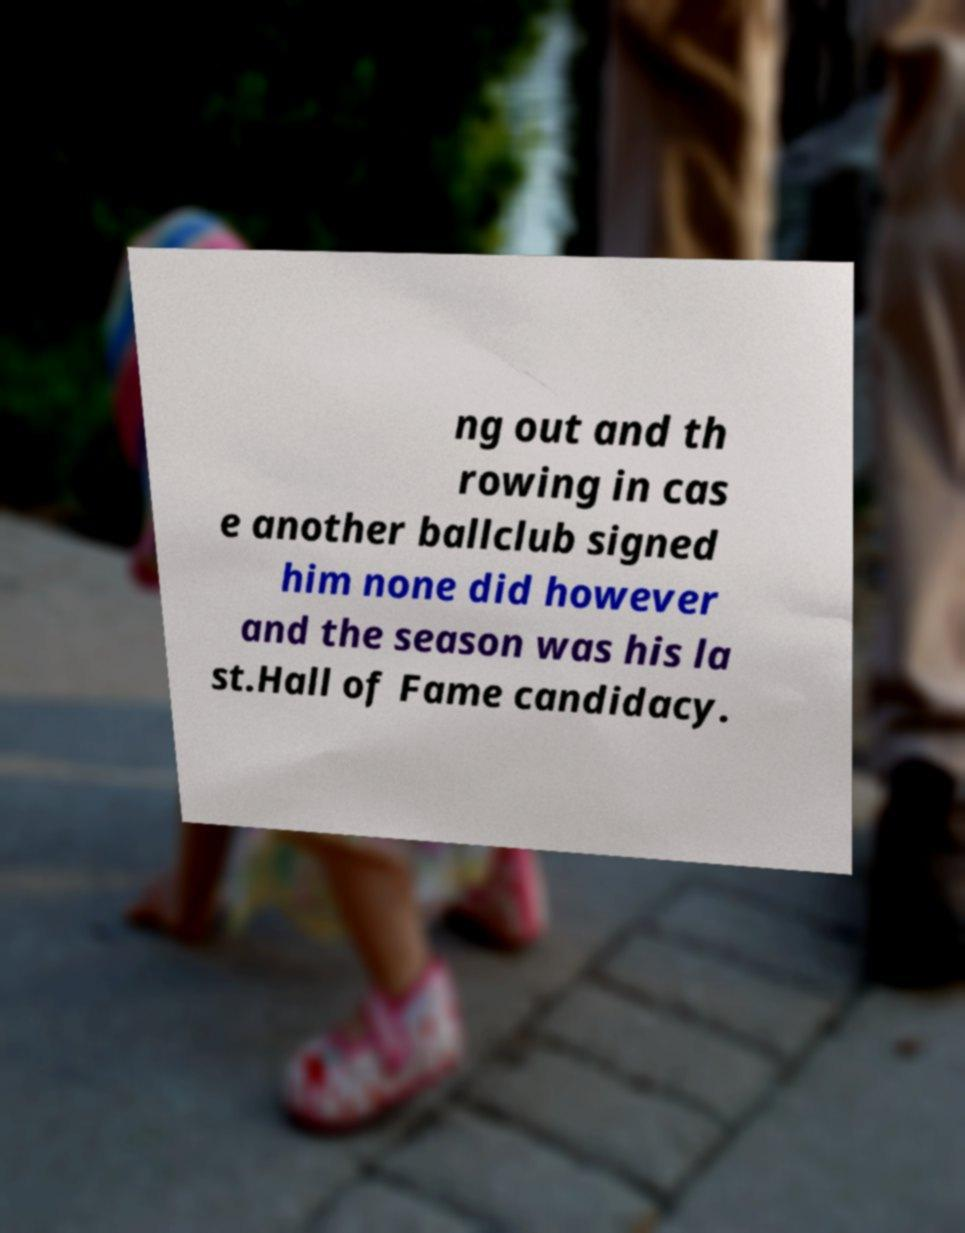What messages or text are displayed in this image? I need them in a readable, typed format. ng out and th rowing in cas e another ballclub signed him none did however and the season was his la st.Hall of Fame candidacy. 